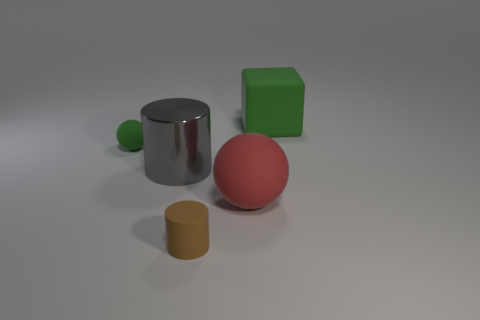Subtract all blocks. How many objects are left? 4 Subtract 1 blocks. How many blocks are left? 0 Add 2 large green cubes. How many large green cubes are left? 3 Add 2 large green things. How many large green things exist? 3 Add 4 big gray cylinders. How many objects exist? 9 Subtract 0 red blocks. How many objects are left? 5 Subtract all cyan cubes. Subtract all blue cylinders. How many cubes are left? 1 Subtract all gray cylinders. How many purple spheres are left? 0 Subtract all cylinders. Subtract all large cylinders. How many objects are left? 2 